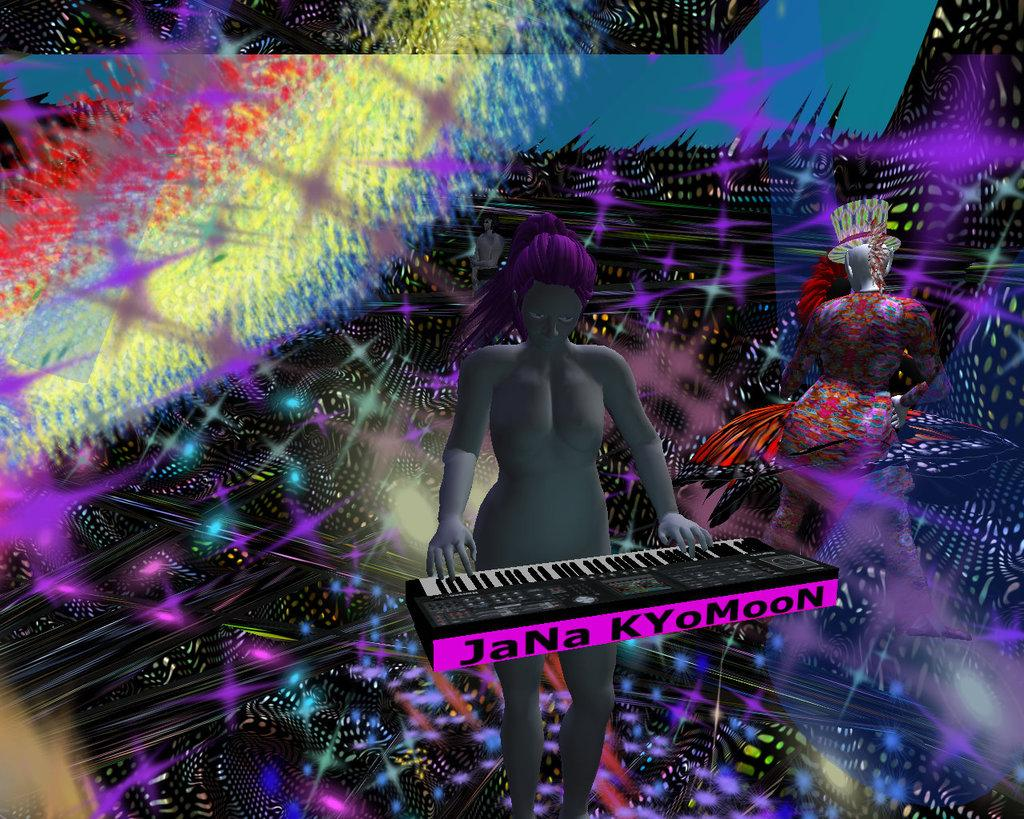What type of image is being described? The image is an animated picture. Who is present in the image? There is a woman in the image. What is the woman doing in the image? The woman is standing and playing a piano keyboard. How would you describe the background of the image? The background of the image is colorful. How many chickens are sitting on the piano keyboard in the image? There are no chickens present in the image, and they are not sitting on the piano keyboard. What type of tin is being used by the woman in the image? There is no tin present in the image, and the woman is not using any tin. 